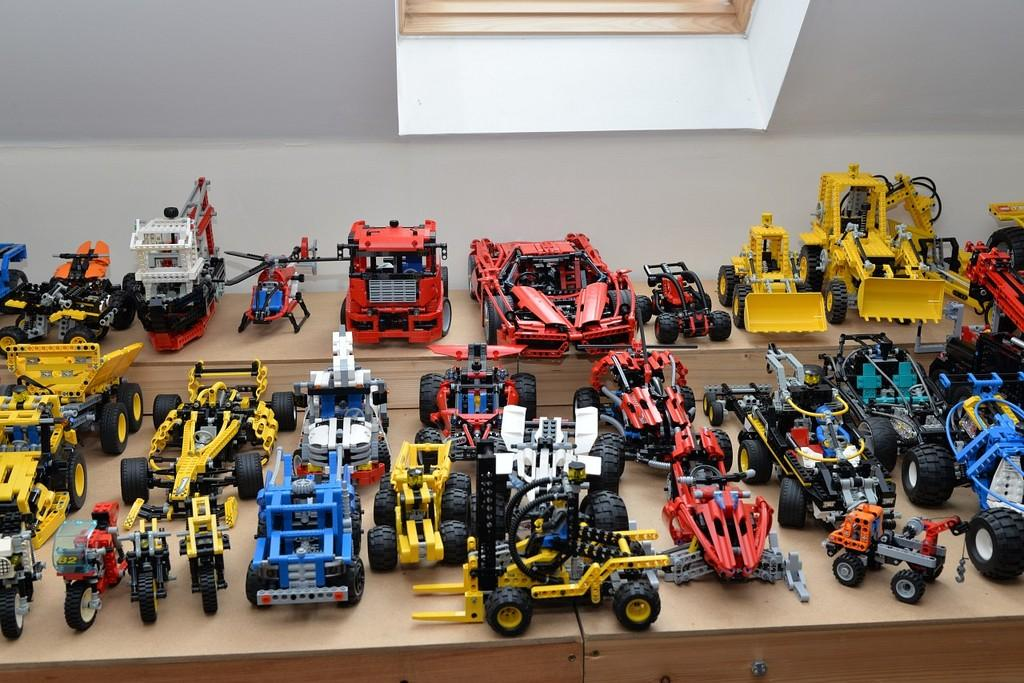What objects can be seen on the table in the image? There are different types of toys on the table in the image. What can be seen in the background of the image? There is a window visible at the top of the image. What type of doctor is attending to the woman in the image? There is no doctor or woman present in the image; it only features toys on a table and a window in the background. 